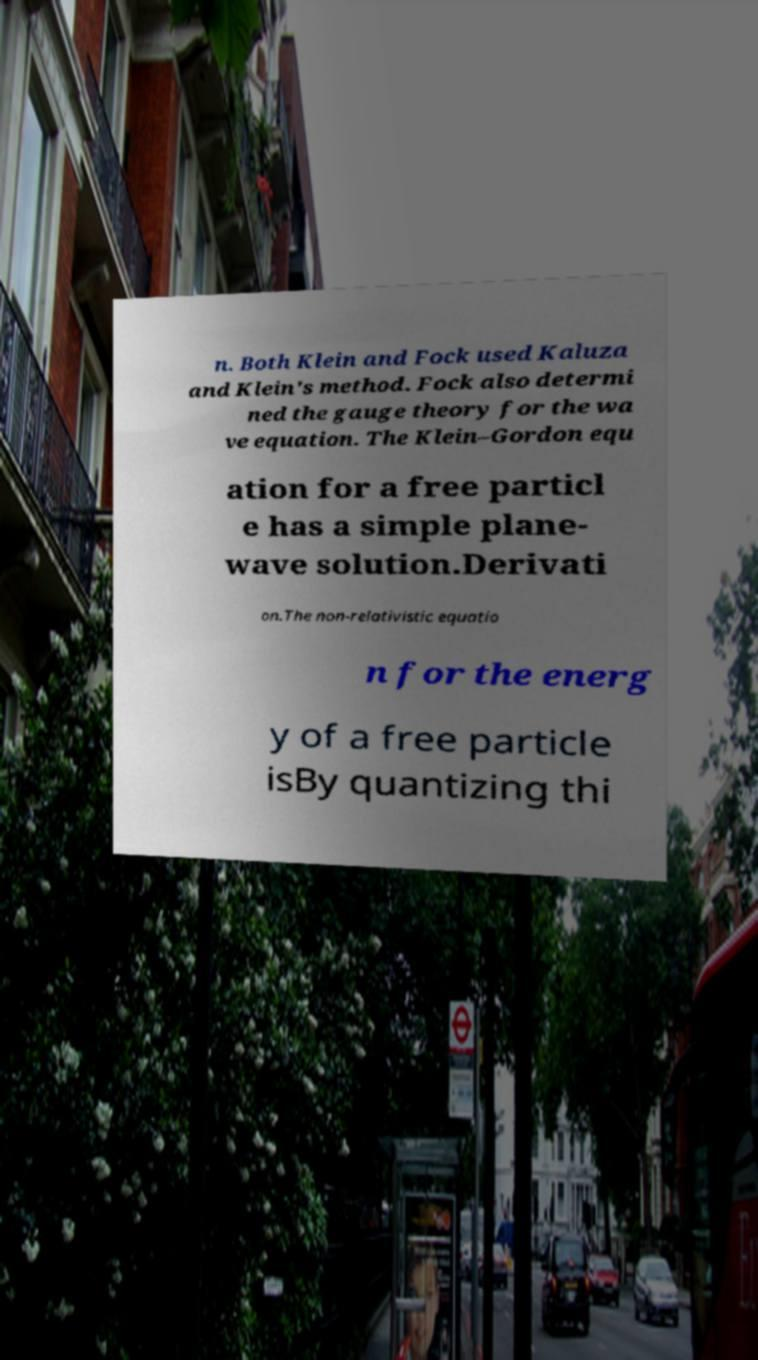Please read and relay the text visible in this image. What does it say? n. Both Klein and Fock used Kaluza and Klein's method. Fock also determi ned the gauge theory for the wa ve equation. The Klein–Gordon equ ation for a free particl e has a simple plane- wave solution.Derivati on.The non-relativistic equatio n for the energ y of a free particle isBy quantizing thi 